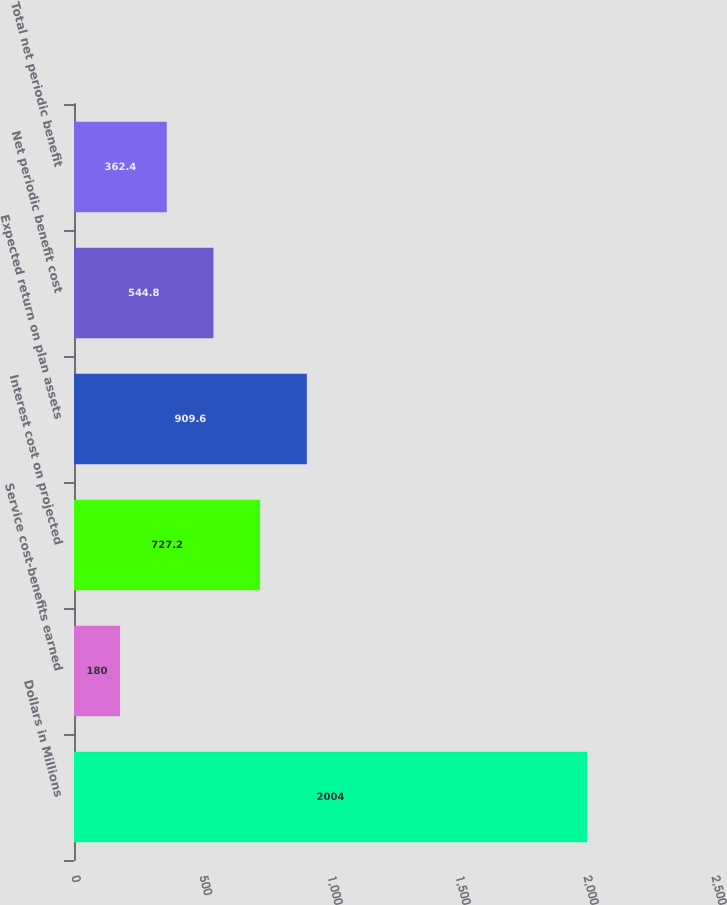Convert chart to OTSL. <chart><loc_0><loc_0><loc_500><loc_500><bar_chart><fcel>Dollars in Millions<fcel>Service cost-benefits earned<fcel>Interest cost on projected<fcel>Expected return on plan assets<fcel>Net periodic benefit cost<fcel>Total net periodic benefit<nl><fcel>2004<fcel>180<fcel>727.2<fcel>909.6<fcel>544.8<fcel>362.4<nl></chart> 